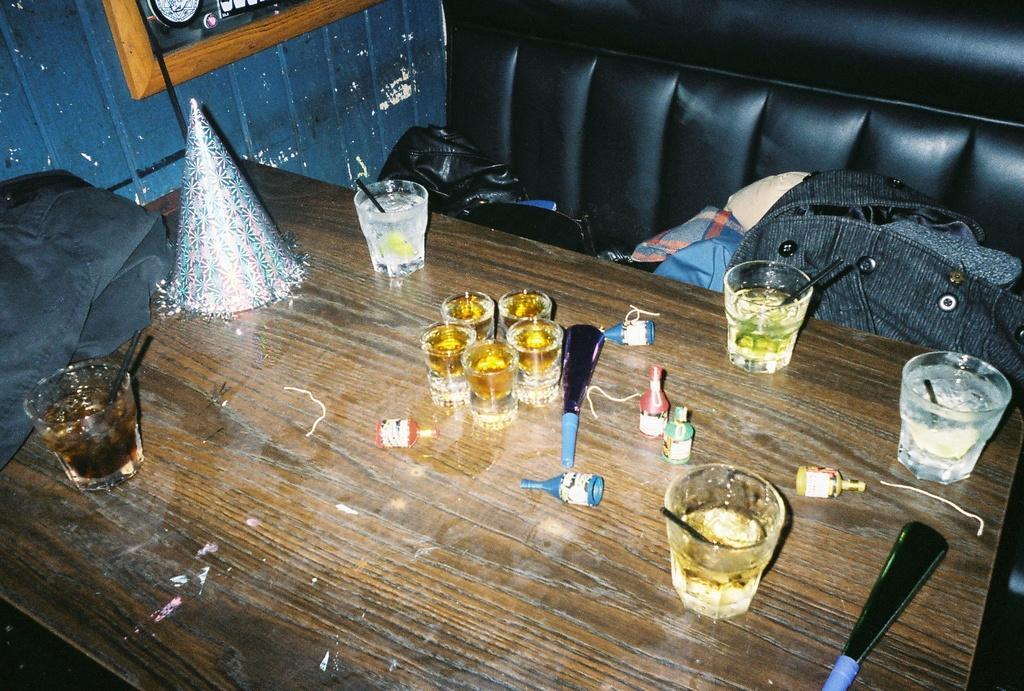Describe this image in one or two sentences. On this table there is a jacket, glasses and cap. On this couch there are clothes. Picture on wall. 